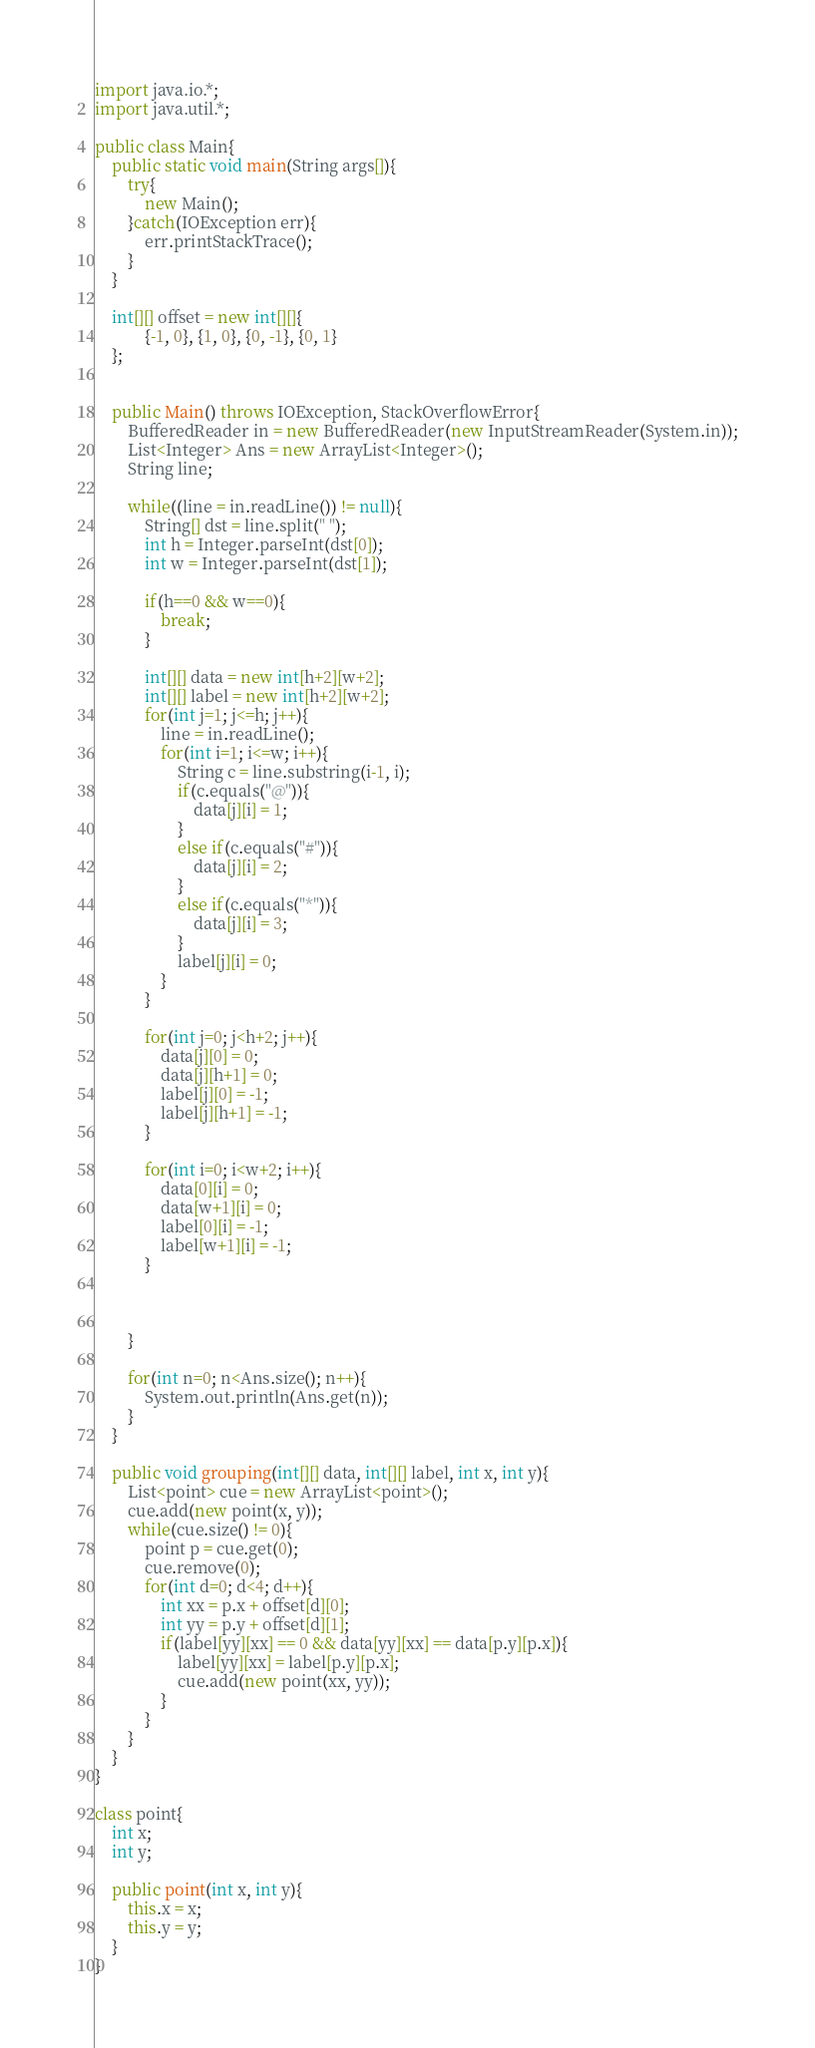<code> <loc_0><loc_0><loc_500><loc_500><_Java_>import java.io.*;
import java.util.*;

public class Main{
	public static void main(String args[]){
		try{
			new Main();
		}catch(IOException err){
			err.printStackTrace();
		}
	}
	
	int[][] offset = new int[][]{
			{-1, 0}, {1, 0}, {0, -1}, {0, 1}
	};


	public Main() throws IOException, StackOverflowError{
		BufferedReader in = new BufferedReader(new InputStreamReader(System.in));
		List<Integer> Ans = new ArrayList<Integer>();
		String line;

		while((line = in.readLine()) != null){
			String[] dst = line.split(" ");
			int h = Integer.parseInt(dst[0]);
			int w = Integer.parseInt(dst[1]);

			if(h==0 && w==0){
				break;
			}

			int[][] data = new int[h+2][w+2];
			int[][] label = new int[h+2][w+2];
			for(int j=1; j<=h; j++){
				line = in.readLine();
				for(int i=1; i<=w; i++){
					String c = line.substring(i-1, i);
					if(c.equals("@")){
						data[j][i] = 1;
					}
					else if(c.equals("#")){
						data[j][i] = 2;
					}
					else if(c.equals("*")){
						data[j][i] = 3;
					}
					label[j][i] = 0;
				}
			}
			
			for(int j=0; j<h+2; j++){
				data[j][0] = 0;
				data[j][h+1] = 0;
				label[j][0] = -1;
				label[j][h+1] = -1;
			}
			
			for(int i=0; i<w+2; i++){
				data[0][i] = 0;
				data[w+1][i] = 0;
				label[0][i] = -1;
				label[w+1][i] = -1;
			}
			

		
		}

		for(int n=0; n<Ans.size(); n++){
			System.out.println(Ans.get(n));
		}
	}

	public void grouping(int[][] data, int[][] label, int x, int y){
		List<point> cue = new ArrayList<point>();
		cue.add(new point(x, y));
		while(cue.size() != 0){
			point p = cue.get(0);
			cue.remove(0);
			for(int d=0; d<4; d++){
				int xx = p.x + offset[d][0];
				int yy = p.y + offset[d][1];
				if(label[yy][xx] == 0 && data[yy][xx] == data[p.y][p.x]){
					label[yy][xx] = label[p.y][p.x];
					cue.add(new point(xx, yy));
				}
			}
		}
	}
}

class point{
	int x;
	int y;
	
	public point(int x, int y){
		this.x = x;
		this.y = y;
	}
}</code> 